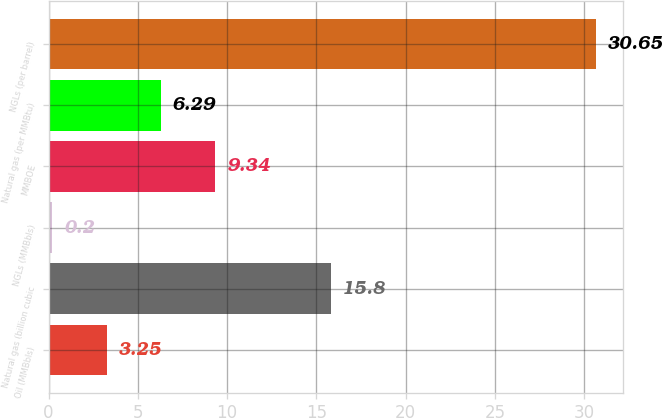<chart> <loc_0><loc_0><loc_500><loc_500><bar_chart><fcel>Oil (MMBbls)<fcel>Natural gas (billion cubic<fcel>NGLs (MMBbls)<fcel>MMBOE<fcel>Natural gas (per MMBtu)<fcel>NGLs (per barrel)<nl><fcel>3.25<fcel>15.8<fcel>0.2<fcel>9.34<fcel>6.29<fcel>30.65<nl></chart> 